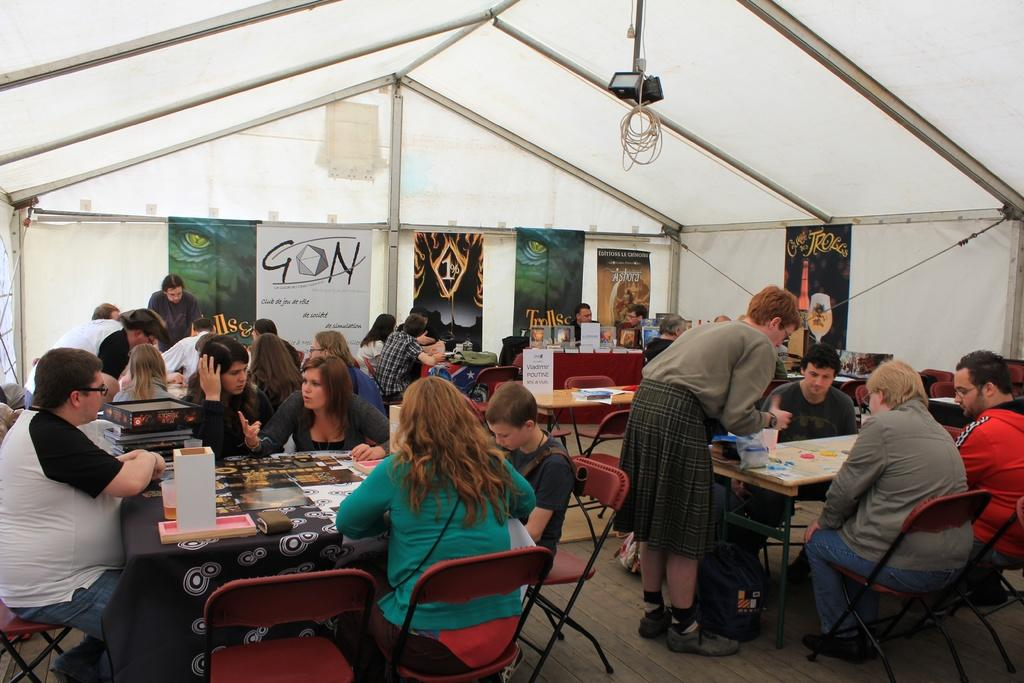How many people are in the image? There are people in the image, but the exact number is not specified. What are some of the people doing in the image? Some people are standing, and some are sitting on chairs. What type of furniture is present in the image? There are chairs and tables in the image. What can be found on the tables? There are items on the tables. What type of fowl can be seen walking around the tables in the image? There is no fowl present in the image; it only features people, chairs, and tables. How many cows are visible in the image? There are no cows present in the image. 